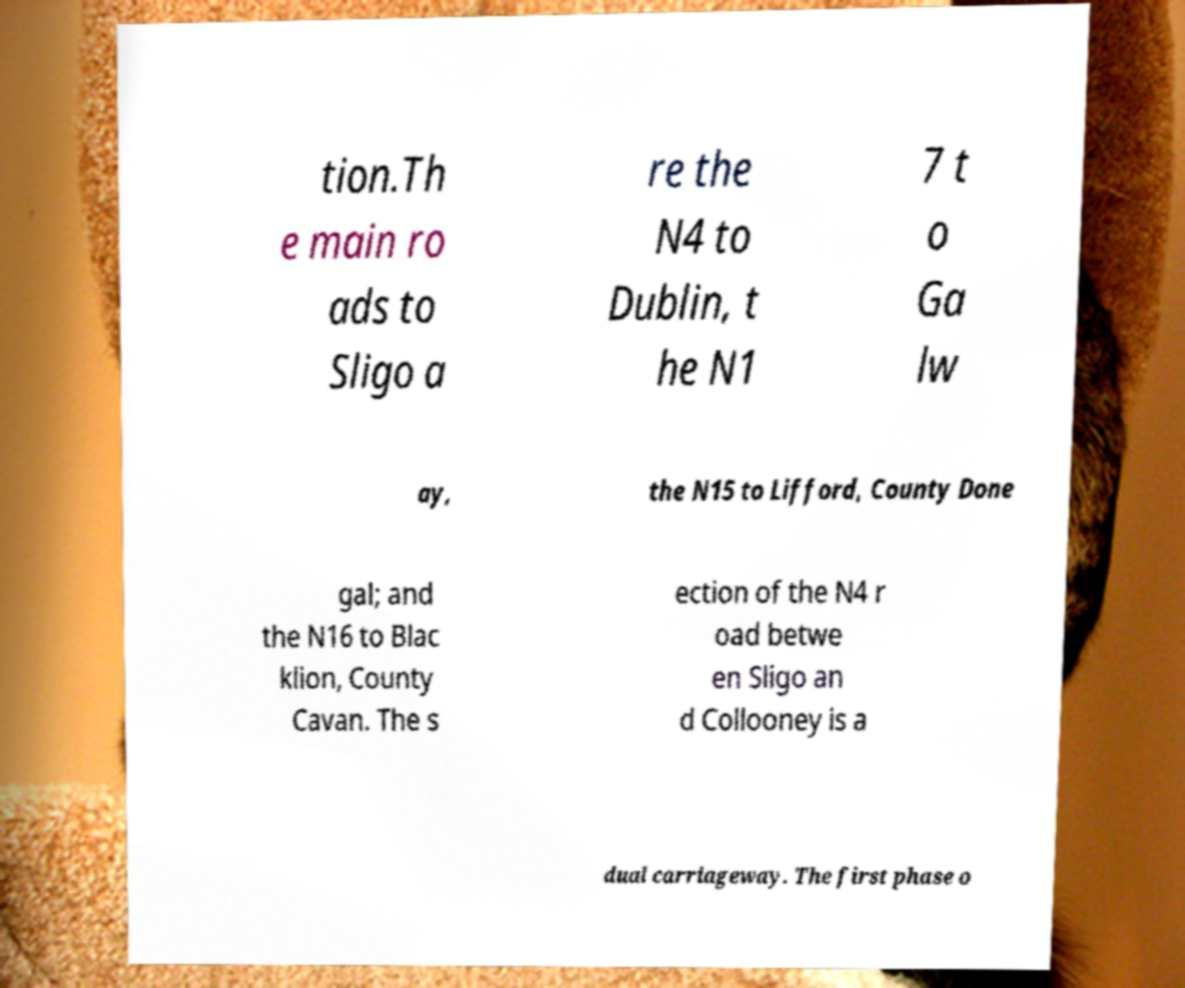Please read and relay the text visible in this image. What does it say? tion.Th e main ro ads to Sligo a re the N4 to Dublin, t he N1 7 t o Ga lw ay, the N15 to Lifford, County Done gal; and the N16 to Blac klion, County Cavan. The s ection of the N4 r oad betwe en Sligo an d Collooney is a dual carriageway. The first phase o 